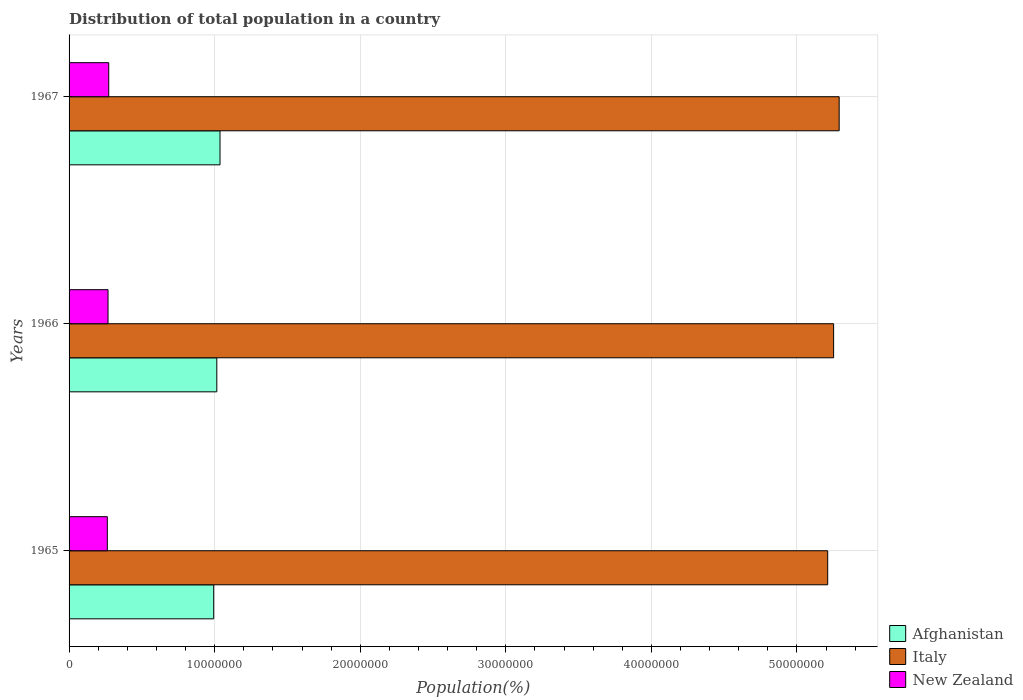Are the number of bars per tick equal to the number of legend labels?
Provide a short and direct response. Yes. How many bars are there on the 1st tick from the top?
Offer a terse response. 3. How many bars are there on the 3rd tick from the bottom?
Provide a short and direct response. 3. What is the label of the 1st group of bars from the top?
Provide a short and direct response. 1967. What is the population of in Afghanistan in 1967?
Your answer should be very brief. 1.04e+07. Across all years, what is the maximum population of in Afghanistan?
Make the answer very short. 1.04e+07. Across all years, what is the minimum population of in New Zealand?
Make the answer very short. 2.63e+06. In which year was the population of in New Zealand maximum?
Offer a very short reply. 1967. In which year was the population of in Afghanistan minimum?
Keep it short and to the point. 1965. What is the total population of in Italy in the graph?
Keep it short and to the point. 1.58e+08. What is the difference between the population of in Italy in 1965 and that in 1967?
Keep it short and to the point. -7.88e+05. What is the difference between the population of in Italy in 1966 and the population of in Afghanistan in 1967?
Provide a succinct answer. 4.22e+07. What is the average population of in Italy per year?
Keep it short and to the point. 5.25e+07. In the year 1965, what is the difference between the population of in Afghanistan and population of in New Zealand?
Offer a very short reply. 7.31e+06. In how many years, is the population of in Afghanistan greater than 22000000 %?
Provide a short and direct response. 0. What is the ratio of the population of in New Zealand in 1965 to that in 1967?
Offer a very short reply. 0.96. Is the difference between the population of in Afghanistan in 1965 and 1967 greater than the difference between the population of in New Zealand in 1965 and 1967?
Offer a terse response. No. What is the difference between the highest and the second highest population of in Afghanistan?
Ensure brevity in your answer.  2.20e+05. What is the difference between the highest and the lowest population of in New Zealand?
Make the answer very short. 9.57e+04. In how many years, is the population of in Italy greater than the average population of in Italy taken over all years?
Your answer should be compact. 2. Is the sum of the population of in Italy in 1965 and 1967 greater than the maximum population of in New Zealand across all years?
Offer a very short reply. Yes. What does the 3rd bar from the top in 1966 represents?
Make the answer very short. Afghanistan. What does the 1st bar from the bottom in 1966 represents?
Make the answer very short. Afghanistan. Is it the case that in every year, the sum of the population of in New Zealand and population of in Afghanistan is greater than the population of in Italy?
Make the answer very short. No. How many bars are there?
Offer a terse response. 9. Are all the bars in the graph horizontal?
Ensure brevity in your answer.  Yes. How many years are there in the graph?
Provide a short and direct response. 3. What is the difference between two consecutive major ticks on the X-axis?
Offer a terse response. 1.00e+07. Does the graph contain any zero values?
Give a very brief answer. No. How are the legend labels stacked?
Provide a succinct answer. Vertical. What is the title of the graph?
Give a very brief answer. Distribution of total population in a country. Does "Malaysia" appear as one of the legend labels in the graph?
Provide a succinct answer. No. What is the label or title of the X-axis?
Keep it short and to the point. Population(%). What is the Population(%) in Afghanistan in 1965?
Ensure brevity in your answer.  9.94e+06. What is the Population(%) in Italy in 1965?
Make the answer very short. 5.21e+07. What is the Population(%) in New Zealand in 1965?
Keep it short and to the point. 2.63e+06. What is the Population(%) in Afghanistan in 1966?
Give a very brief answer. 1.01e+07. What is the Population(%) in Italy in 1966?
Your answer should be compact. 5.25e+07. What is the Population(%) of New Zealand in 1966?
Your answer should be very brief. 2.68e+06. What is the Population(%) of Afghanistan in 1967?
Provide a succinct answer. 1.04e+07. What is the Population(%) of Italy in 1967?
Your answer should be compact. 5.29e+07. What is the Population(%) of New Zealand in 1967?
Give a very brief answer. 2.72e+06. Across all years, what is the maximum Population(%) of Afghanistan?
Provide a short and direct response. 1.04e+07. Across all years, what is the maximum Population(%) in Italy?
Offer a very short reply. 5.29e+07. Across all years, what is the maximum Population(%) of New Zealand?
Keep it short and to the point. 2.72e+06. Across all years, what is the minimum Population(%) in Afghanistan?
Keep it short and to the point. 9.94e+06. Across all years, what is the minimum Population(%) in Italy?
Your response must be concise. 5.21e+07. Across all years, what is the minimum Population(%) in New Zealand?
Provide a succinct answer. 2.63e+06. What is the total Population(%) in Afghanistan in the graph?
Give a very brief answer. 3.05e+07. What is the total Population(%) in Italy in the graph?
Offer a terse response. 1.58e+08. What is the total Population(%) of New Zealand in the graph?
Make the answer very short. 8.03e+06. What is the difference between the Population(%) of Afghanistan in 1965 and that in 1966?
Offer a terse response. -2.13e+05. What is the difference between the Population(%) in Italy in 1965 and that in 1966?
Provide a succinct answer. -4.07e+05. What is the difference between the Population(%) in New Zealand in 1965 and that in 1966?
Provide a short and direct response. -4.75e+04. What is the difference between the Population(%) in Afghanistan in 1965 and that in 1967?
Offer a very short reply. -4.33e+05. What is the difference between the Population(%) in Italy in 1965 and that in 1967?
Offer a very short reply. -7.88e+05. What is the difference between the Population(%) of New Zealand in 1965 and that in 1967?
Offer a terse response. -9.57e+04. What is the difference between the Population(%) in Afghanistan in 1966 and that in 1967?
Offer a very short reply. -2.20e+05. What is the difference between the Population(%) of Italy in 1966 and that in 1967?
Keep it short and to the point. -3.82e+05. What is the difference between the Population(%) of New Zealand in 1966 and that in 1967?
Give a very brief answer. -4.82e+04. What is the difference between the Population(%) in Afghanistan in 1965 and the Population(%) in Italy in 1966?
Offer a terse response. -4.26e+07. What is the difference between the Population(%) in Afghanistan in 1965 and the Population(%) in New Zealand in 1966?
Offer a terse response. 7.26e+06. What is the difference between the Population(%) of Italy in 1965 and the Population(%) of New Zealand in 1966?
Your answer should be very brief. 4.94e+07. What is the difference between the Population(%) of Afghanistan in 1965 and the Population(%) of Italy in 1967?
Your response must be concise. -4.30e+07. What is the difference between the Population(%) in Afghanistan in 1965 and the Population(%) in New Zealand in 1967?
Offer a terse response. 7.21e+06. What is the difference between the Population(%) of Italy in 1965 and the Population(%) of New Zealand in 1967?
Provide a short and direct response. 4.94e+07. What is the difference between the Population(%) of Afghanistan in 1966 and the Population(%) of Italy in 1967?
Your answer should be compact. -4.28e+07. What is the difference between the Population(%) of Afghanistan in 1966 and the Population(%) of New Zealand in 1967?
Offer a terse response. 7.42e+06. What is the difference between the Population(%) of Italy in 1966 and the Population(%) of New Zealand in 1967?
Offer a very short reply. 4.98e+07. What is the average Population(%) of Afghanistan per year?
Make the answer very short. 1.02e+07. What is the average Population(%) in Italy per year?
Your response must be concise. 5.25e+07. What is the average Population(%) in New Zealand per year?
Provide a short and direct response. 2.68e+06. In the year 1965, what is the difference between the Population(%) of Afghanistan and Population(%) of Italy?
Offer a terse response. -4.22e+07. In the year 1965, what is the difference between the Population(%) of Afghanistan and Population(%) of New Zealand?
Make the answer very short. 7.31e+06. In the year 1965, what is the difference between the Population(%) in Italy and Population(%) in New Zealand?
Give a very brief answer. 4.95e+07. In the year 1966, what is the difference between the Population(%) of Afghanistan and Population(%) of Italy?
Your answer should be compact. -4.24e+07. In the year 1966, what is the difference between the Population(%) in Afghanistan and Population(%) in New Zealand?
Ensure brevity in your answer.  7.47e+06. In the year 1966, what is the difference between the Population(%) in Italy and Population(%) in New Zealand?
Offer a very short reply. 4.98e+07. In the year 1967, what is the difference between the Population(%) of Afghanistan and Population(%) of Italy?
Offer a terse response. -4.25e+07. In the year 1967, what is the difference between the Population(%) in Afghanistan and Population(%) in New Zealand?
Offer a terse response. 7.64e+06. In the year 1967, what is the difference between the Population(%) in Italy and Population(%) in New Zealand?
Keep it short and to the point. 5.02e+07. What is the ratio of the Population(%) of Italy in 1965 to that in 1966?
Offer a terse response. 0.99. What is the ratio of the Population(%) of New Zealand in 1965 to that in 1966?
Keep it short and to the point. 0.98. What is the ratio of the Population(%) of Afghanistan in 1965 to that in 1967?
Offer a terse response. 0.96. What is the ratio of the Population(%) in Italy in 1965 to that in 1967?
Your response must be concise. 0.99. What is the ratio of the Population(%) of New Zealand in 1965 to that in 1967?
Provide a short and direct response. 0.96. What is the ratio of the Population(%) of Afghanistan in 1966 to that in 1967?
Provide a short and direct response. 0.98. What is the ratio of the Population(%) of Italy in 1966 to that in 1967?
Make the answer very short. 0.99. What is the ratio of the Population(%) in New Zealand in 1966 to that in 1967?
Your answer should be compact. 0.98. What is the difference between the highest and the second highest Population(%) of Afghanistan?
Keep it short and to the point. 2.20e+05. What is the difference between the highest and the second highest Population(%) in Italy?
Give a very brief answer. 3.82e+05. What is the difference between the highest and the second highest Population(%) of New Zealand?
Provide a succinct answer. 4.82e+04. What is the difference between the highest and the lowest Population(%) of Afghanistan?
Give a very brief answer. 4.33e+05. What is the difference between the highest and the lowest Population(%) of Italy?
Your response must be concise. 7.88e+05. What is the difference between the highest and the lowest Population(%) of New Zealand?
Your answer should be very brief. 9.57e+04. 